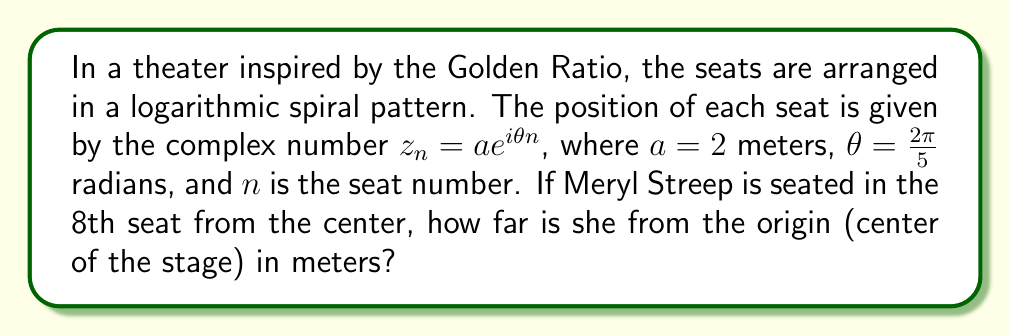What is the answer to this math problem? Let's approach this step-by-step:

1) The general formula for the position of each seat is $z_n = ae^{i\theta n}$, where:
   $a = 2$ meters
   $\theta = \frac{2\pi}{5}$ radians
   $n = 8$ (Meryl Streep's seat number)

2) Substituting these values into the formula:
   $z_8 = 2e^{i\frac{2\pi}{5}8}$

3) Simplify the exponent:
   $z_8 = 2e^{i\frac{16\pi}{5}}$

4) To find the distance from the origin, we need to calculate the modulus (absolute value) of this complex number:
   $|z_8| = |2e^{i\frac{16\pi}{5}}|$

5) The modulus of a complex exponential is equal to the base raised to the real part of the exponent. Since the exponent here is purely imaginary, the modulus is simply the coefficient:
   $|z_8| = 2$

Therefore, Meryl Streep is seated 2 meters from the center of the stage.
Answer: 2 meters 